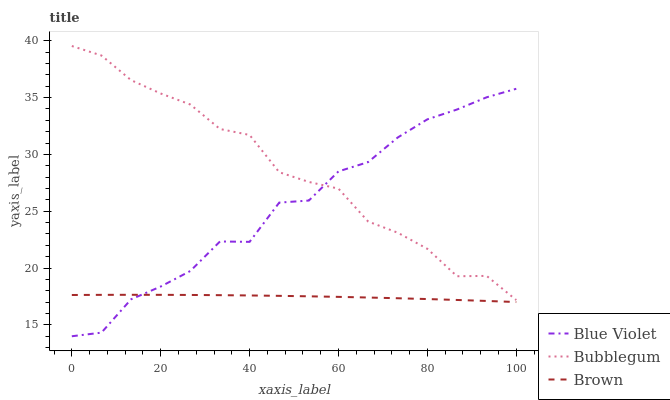Does Brown have the minimum area under the curve?
Answer yes or no. Yes. Does Bubblegum have the maximum area under the curve?
Answer yes or no. Yes. Does Blue Violet have the minimum area under the curve?
Answer yes or no. No. Does Blue Violet have the maximum area under the curve?
Answer yes or no. No. Is Brown the smoothest?
Answer yes or no. Yes. Is Blue Violet the roughest?
Answer yes or no. Yes. Is Bubblegum the smoothest?
Answer yes or no. No. Is Bubblegum the roughest?
Answer yes or no. No. Does Blue Violet have the lowest value?
Answer yes or no. Yes. Does Bubblegum have the lowest value?
Answer yes or no. No. Does Bubblegum have the highest value?
Answer yes or no. Yes. Does Blue Violet have the highest value?
Answer yes or no. No. Is Brown less than Bubblegum?
Answer yes or no. Yes. Is Bubblegum greater than Brown?
Answer yes or no. Yes. Does Blue Violet intersect Brown?
Answer yes or no. Yes. Is Blue Violet less than Brown?
Answer yes or no. No. Is Blue Violet greater than Brown?
Answer yes or no. No. Does Brown intersect Bubblegum?
Answer yes or no. No. 